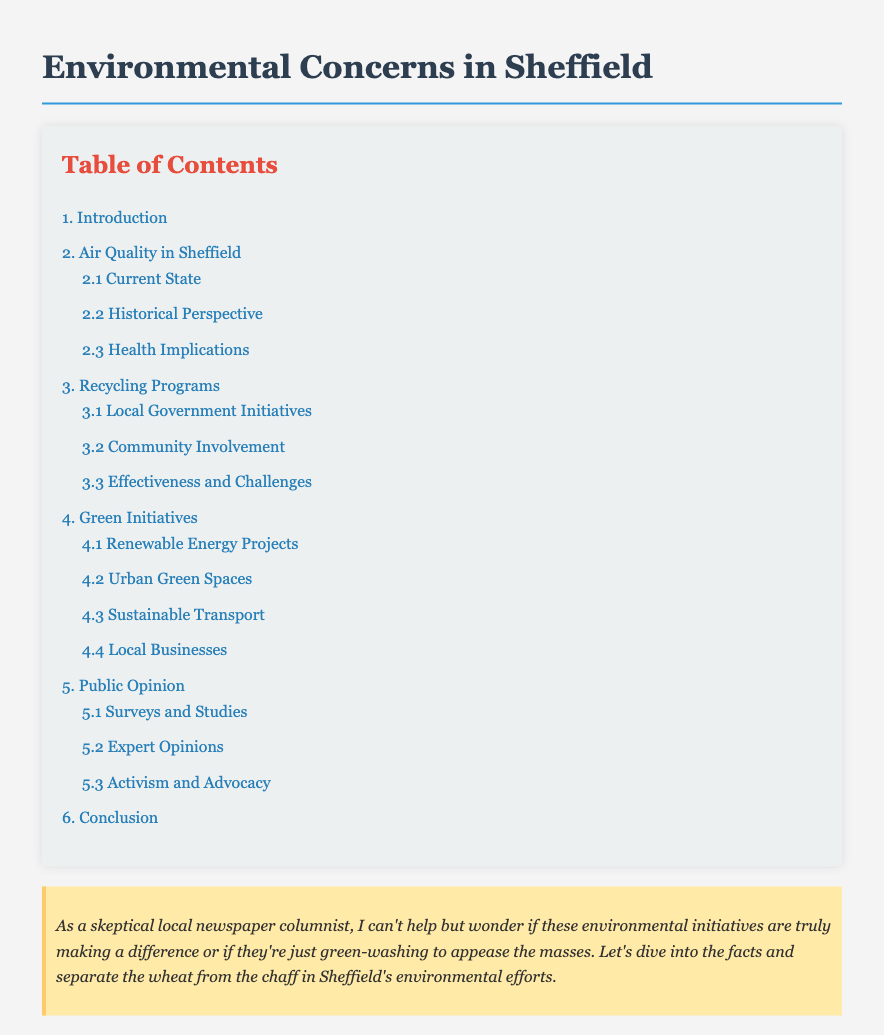What is the title of the document? The title of the document is found in the head section of the HTML code.
Answer: Environmental Concerns in Sheffield What is section 2 about? Section 2 in the table of contents is dedicated to air quality issues specific to Sheffield.
Answer: Air Quality in Sheffield How many subsections are there under "3. Recycling Programs"? The number of subsections can be determined by counting the nested items under section 3.
Answer: 3 What is the title of subsection 4.1? The title for subsection 4.1 is listed directly under section 4.
Answer: Renewable Energy Projects Which section discusses public opinion? The section that covers public opinion is clearly labeled within the table of contents.
Answer: 5. Public Opinion What color is the background of the document? The background color is specified in the CSS styles within the document.
Answer: #f4f4f4 How many main sections are there in the document? The total number of main sections can be counted from the top-level items in the table of contents.
Answer: 6 What does the skeptical note suggest? The skeptical note provides a hint about the author's perspective on the initiatives discussed.
Answer: Doubts about green-washing 